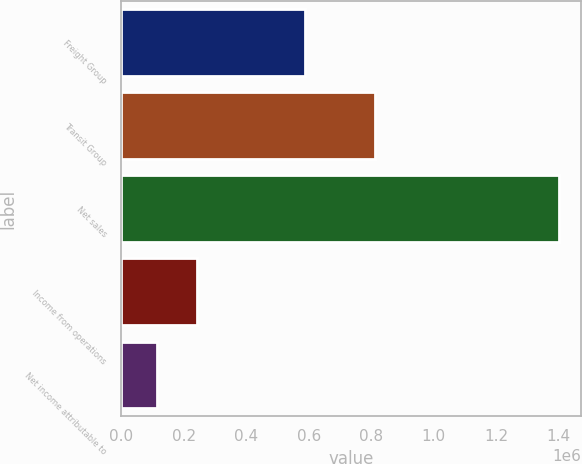Convert chart. <chart><loc_0><loc_0><loc_500><loc_500><bar_chart><fcel>Freight Group<fcel>Transit Group<fcel>Net sales<fcel>Income from operations<fcel>Net income attributable to<nl><fcel>588399<fcel>813217<fcel>1.40162e+06<fcel>243711<fcel>115055<nl></chart> 